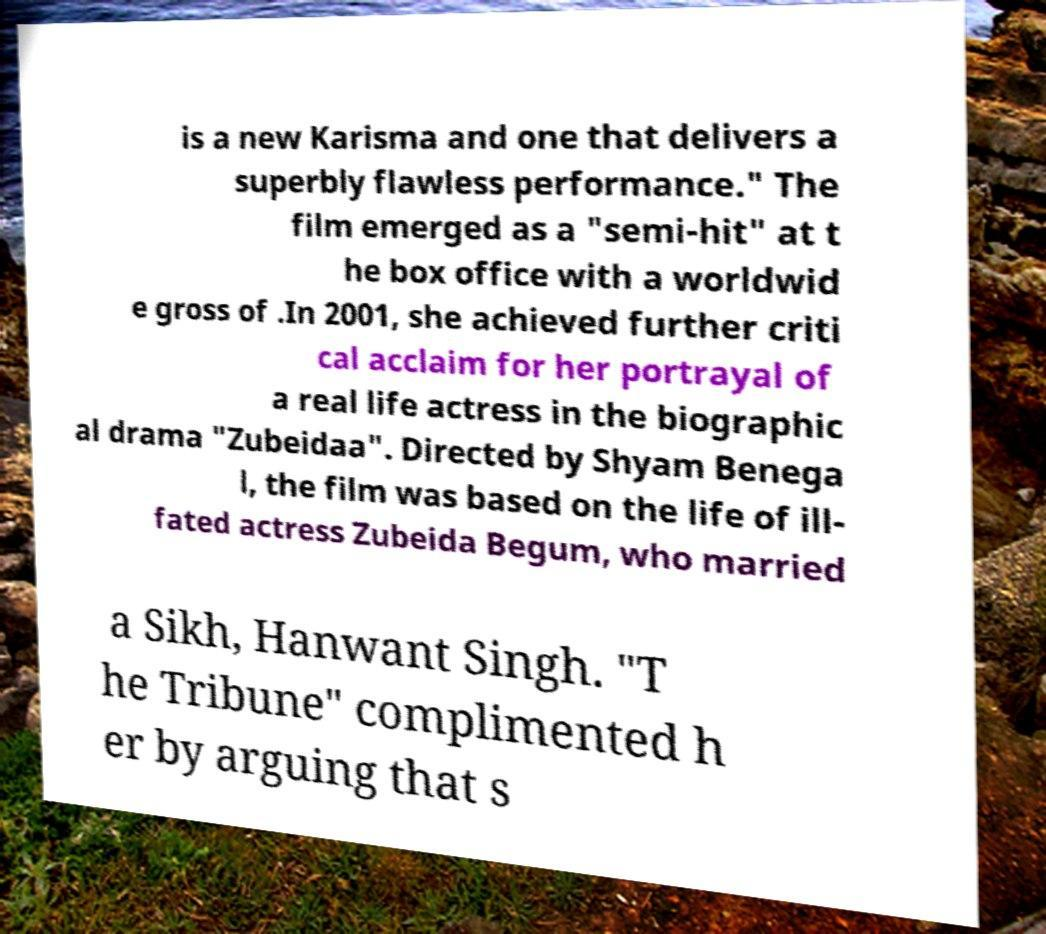For documentation purposes, I need the text within this image transcribed. Could you provide that? is a new Karisma and one that delivers a superbly flawless performance." The film emerged as a "semi-hit" at t he box office with a worldwid e gross of .In 2001, she achieved further criti cal acclaim for her portrayal of a real life actress in the biographic al drama "Zubeidaa". Directed by Shyam Benega l, the film was based on the life of ill- fated actress Zubeida Begum, who married a Sikh, Hanwant Singh. "T he Tribune" complimented h er by arguing that s 